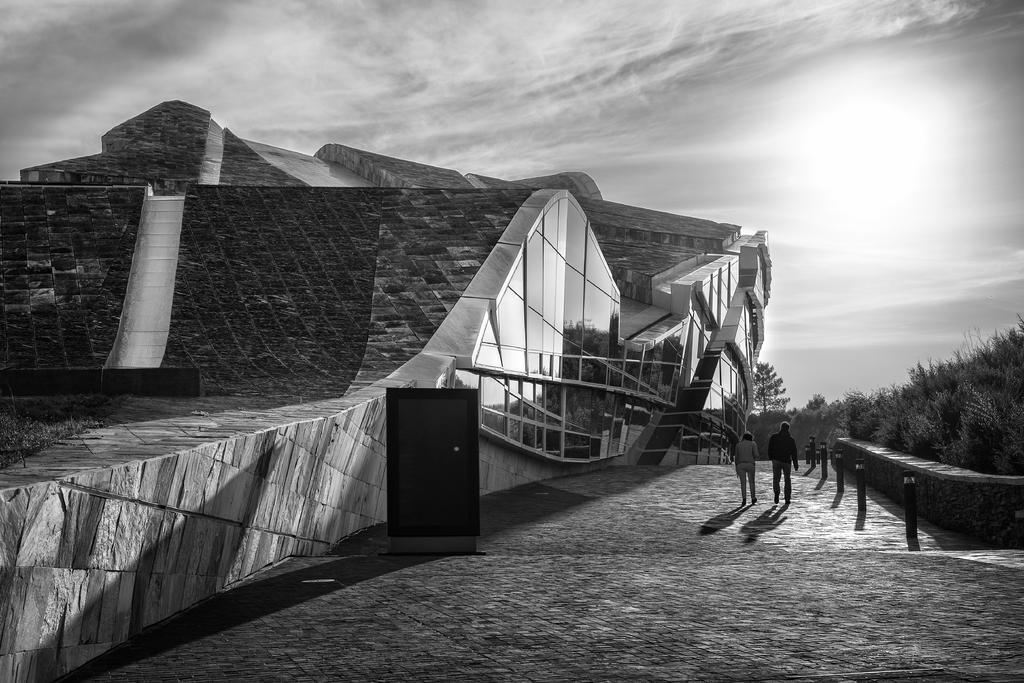Can you describe this image briefly? In this image in the center there is a building and there are some people who are walking. On the right side there are some trees at the bottom there is a walkway. At the top of the image there is sky. 